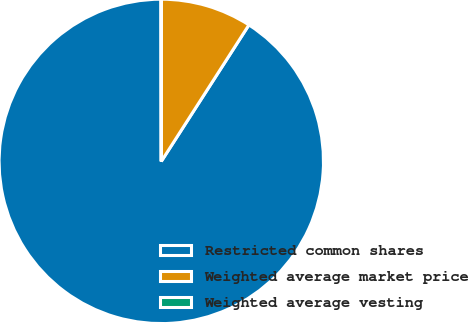<chart> <loc_0><loc_0><loc_500><loc_500><pie_chart><fcel>Restricted common shares<fcel>Weighted average market price<fcel>Weighted average vesting<nl><fcel>90.9%<fcel>9.09%<fcel>0.01%<nl></chart> 